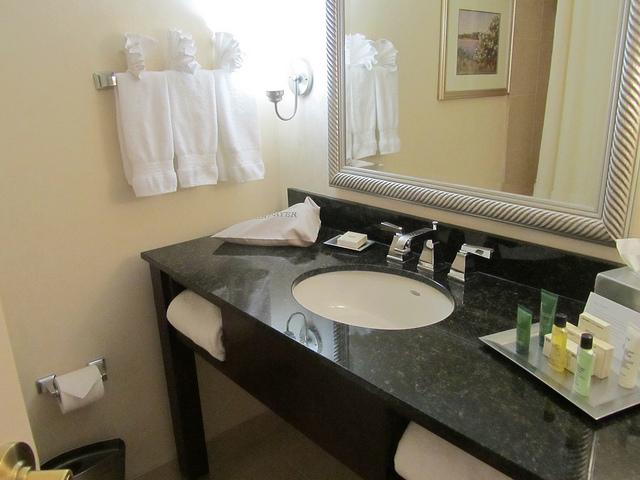Is this a hotel?
Answer briefly. Yes. What is the object in the picture on the wall?
Give a very brief answer. Mirror. Is there a medicine cabinet?
Answer briefly. No. Does this bathroom need to be fixed?
Concise answer only. No. How many rolls of toilet paper are there?
Answer briefly. 1. How many towels are there?
Be succinct. 3. Where did the owner of this bathroom purchase the sink bowl?
Give a very brief answer. Home depot. Is the sink clean?
Keep it brief. Yes. What is the vanity made of?
Short answer required. Marble. How many photos are show on the wall?
Concise answer only. 1. Can the photographer's reflection be seen?
Quick response, please. No. Are there flowers on the wall?
Answer briefly. No. How many lights are there?
Write a very short answer. 1. What color is the sink?
Write a very short answer. White. How many towels are hanging on the wall?
Give a very brief answer. 3. Is the mirror round?
Keep it brief. No. What shape is the bathroom mirror?
Be succinct. Square. Is the sink in this room black?
Short answer required. No. What color is the walls in the room?
Short answer required. Cream. What is unusual about the wall above the sink?
Give a very brief answer. Mirror. How many mirrors are pictured?
Concise answer only. 1. What color are the towels?
Keep it brief. White. Is there a reflection in the mirror?
Keep it brief. Yes. Is this a real bathroom?
Be succinct. Yes. What two color towels are in this color scheme?
Write a very short answer. White. Is this a hotel or home bathroom?
Short answer required. Hotel. Is the room empty?
Be succinct. No. How many non-duplicate curtains are there?
Answer briefly. 1. How many mirrors can you see?
Short answer required. 1. What is in the top of the mirror reflection?
Keep it brief. Picture. 